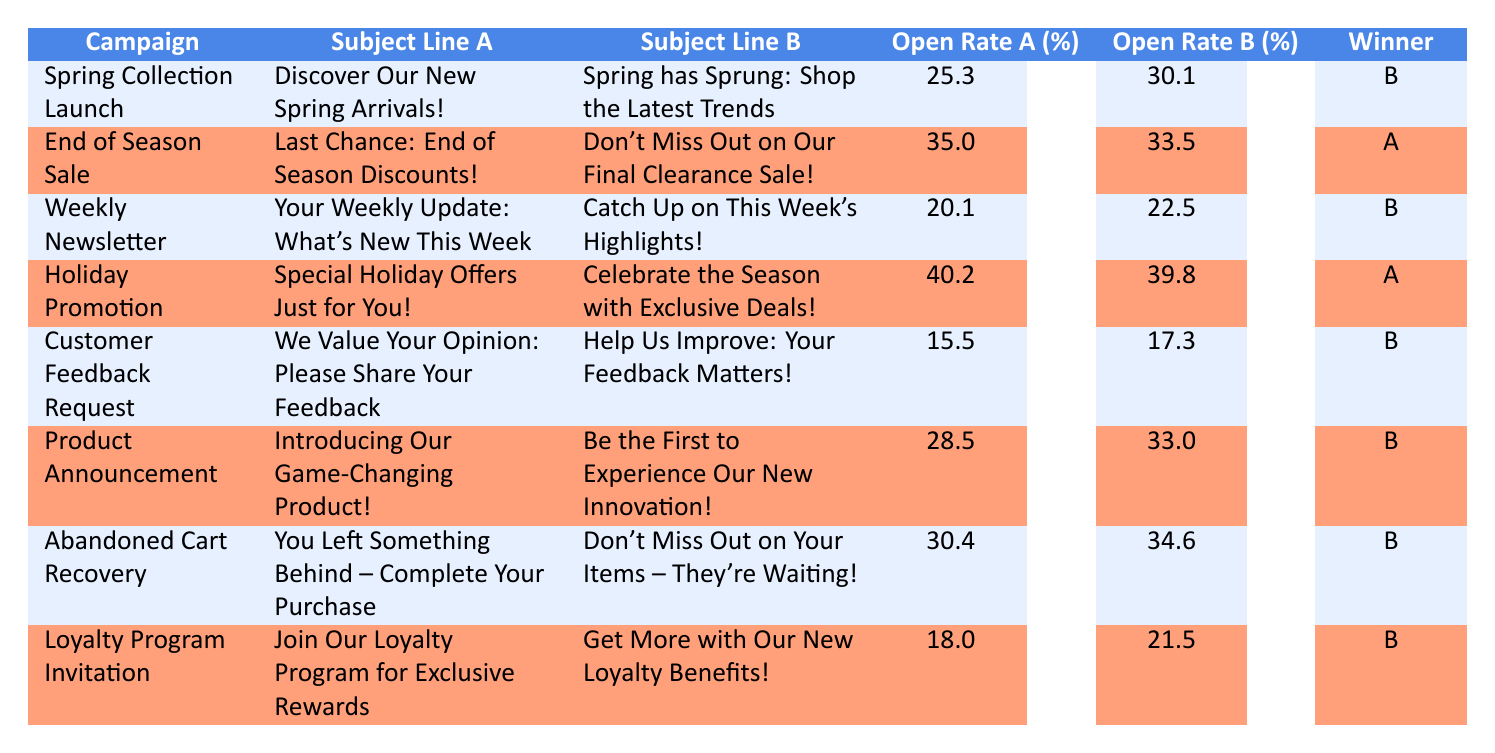What is the winning subject line for the "Spring Collection Launch" campaign? The winning subject line can be found in the "winner" column for the campaign "Spring Collection Launch." This row has "subject_line_b" as the winner.
Answer: subject_line_b Which subject line received a higher open rate in the "Holiday Promotion" campaign? To find this, we compare the "Open Rate A" and "Open Rate B" values for the "Holiday Promotion" campaign. "Open Rate A" is 40.2% and "Open Rate B" is 39.8%. Since 40.2% is greater than 39.8%, subject_line_a had a higher open rate.
Answer: subject_line_a How many campaigns had subject line B as the winner? We count the number of rows in the "winner" column where the value is "subject_line_b." There are 5 instances of subject_line_b being the winner across the 8 total campaigns listed.
Answer: 5 What is the difference between the open rates of subject line A and subject line B for the "Customer Feedback Request" campaign? For the campaign "Customer Feedback Request," the open rates are 15.5% for subject line A and 17.3% for subject line B. The difference is calculated as 17.3% - 15.5%, which equals 1.8%.
Answer: 1.8 Is the open rate for subject line A always greater than subject line B? We look through the table and see if there is any campaign where subject line A's open rate is not greater than B's. There are 5 instances where A is lower than or equal to B (notably, "Weekly Newsletter" and "Product Announcement"). Therefore, the answer is no.
Answer: No What was the campaign with the lowest open rate for subject line B? We compare the "Open Rate B" values from all campaigns. The lowest value is 17.3% from the "Customer Feedback Request" campaign. Therefore, it has the lowest open rate for subject line B.
Answer: Customer Feedback Request What is the average open rate of subject line B across all campaigns? To calculate this, we sum all the open rates for subject line B: 30.1 + 33.5 + 22.5 + 39.8 + 17.3 + 33.0 + 34.6 + 21.5 = 302.3. We then divide by the number of campaigns, which is 8. Thus, the average open rate for subject line B is 302.3 / 8 = 37.79%.
Answer: 37.79% Which campaign had the highest open rate among all campaigns? We check the "Open Rate A" and "Open Rate B" for all campaigns. The highest open rate appears in the "Holiday Promotion" campaign with 40.2%. Therefore, this campaign had the highest overall open rate.
Answer: Holiday Promotion 